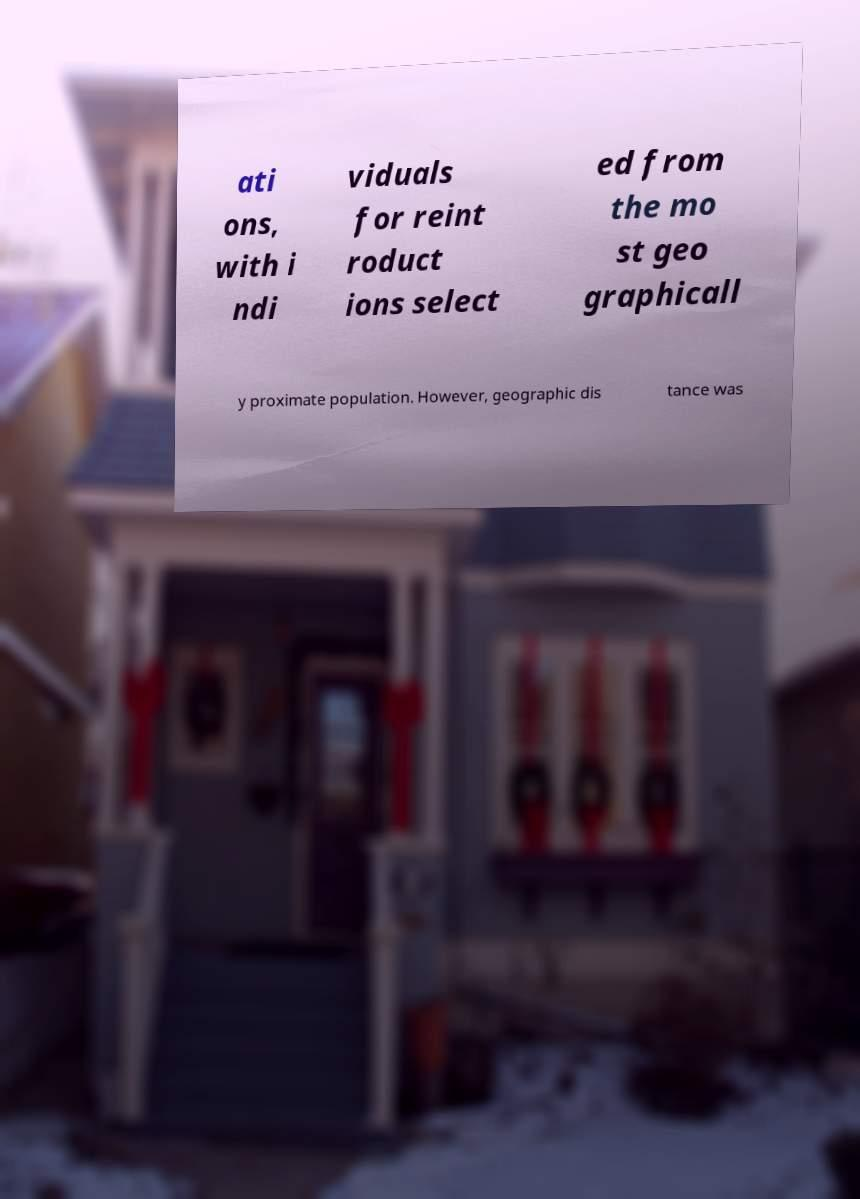There's text embedded in this image that I need extracted. Can you transcribe it verbatim? ati ons, with i ndi viduals for reint roduct ions select ed from the mo st geo graphicall y proximate population. However, geographic dis tance was 